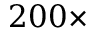<formula> <loc_0><loc_0><loc_500><loc_500>2 0 0 \times</formula> 